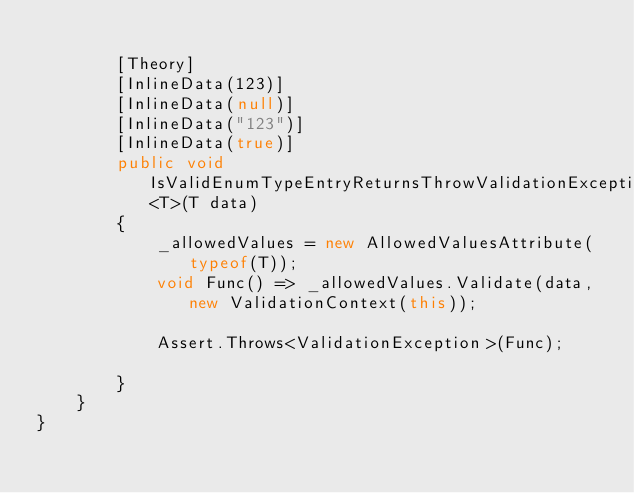<code> <loc_0><loc_0><loc_500><loc_500><_C#_>
        [Theory]
        [InlineData(123)]
        [InlineData(null)]
        [InlineData("123")]
        [InlineData(true)]
        public void IsValidEnumTypeEntryReturnsThrowValidationException<T>(T data)
        {
            _allowedValues = new AllowedValuesAttribute(typeof(T));
            void Func() => _allowedValues.Validate(data, new ValidationContext(this));

            Assert.Throws<ValidationException>(Func);

        }
    }
}
</code> 